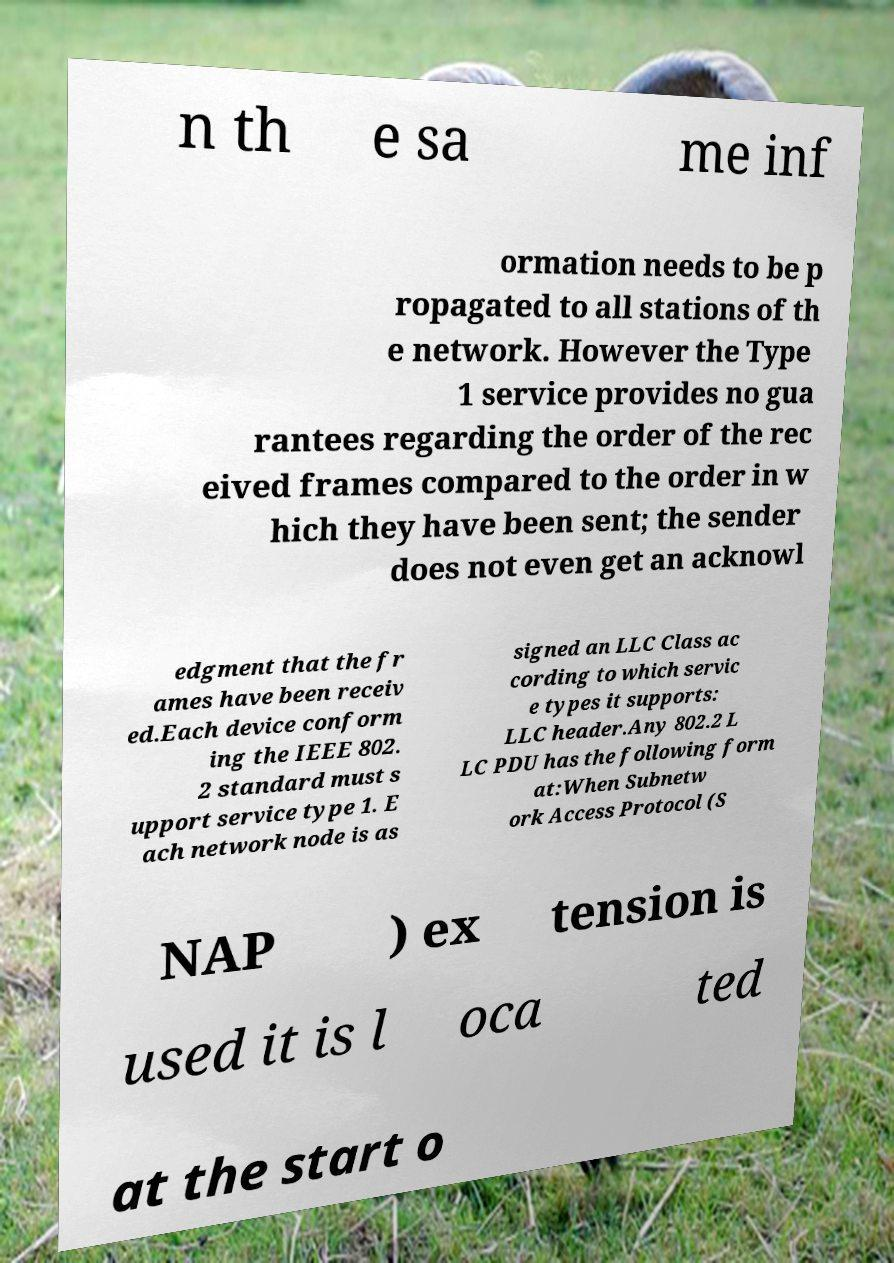Please read and relay the text visible in this image. What does it say? n th e sa me inf ormation needs to be p ropagated to all stations of th e network. However the Type 1 service provides no gua rantees regarding the order of the rec eived frames compared to the order in w hich they have been sent; the sender does not even get an acknowl edgment that the fr ames have been receiv ed.Each device conform ing the IEEE 802. 2 standard must s upport service type 1. E ach network node is as signed an LLC Class ac cording to which servic e types it supports: LLC header.Any 802.2 L LC PDU has the following form at:When Subnetw ork Access Protocol (S NAP ) ex tension is used it is l oca ted at the start o 